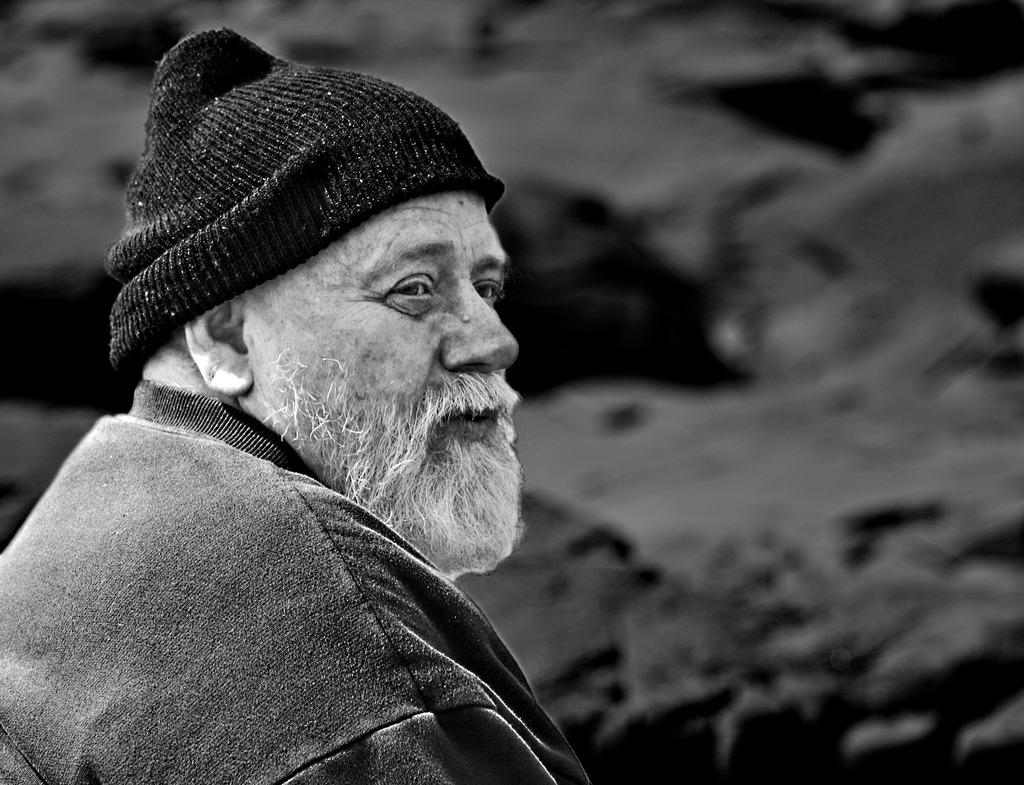What is the color scheme of the image? The image is black and white. Who is present in the image? There is a man in the image. What clothing items is the man wearing? The man is wearing a jerkin and a cap. Can you describe the background of the image? The background of the image is blurry. What type of cannon is present on the street in the image? There is no cannon or street present in the image; it features a man wearing a jerkin and cap against a blurry background. What is the size of the man in the image? The size of the man in the image cannot be determined from the provided facts, as there is no reference point for comparison. 